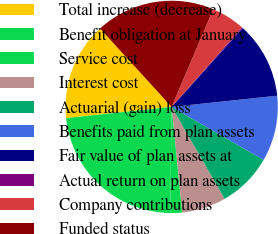Convert chart. <chart><loc_0><loc_0><loc_500><loc_500><pie_chart><fcel>Total increase (decrease)<fcel>Benefit obligation at January<fcel>Service cost<fcel>Interest cost<fcel>Actuarial (gain) loss<fcel>Benefits paid from plan assets<fcel>Fair value of plan assets at<fcel>Actual return on plan assets<fcel>Company contributions<fcel>Funded status<nl><fcel>14.91%<fcel>23.1%<fcel>1.81%<fcel>6.73%<fcel>8.36%<fcel>10.0%<fcel>11.64%<fcel>0.18%<fcel>5.09%<fcel>18.19%<nl></chart> 